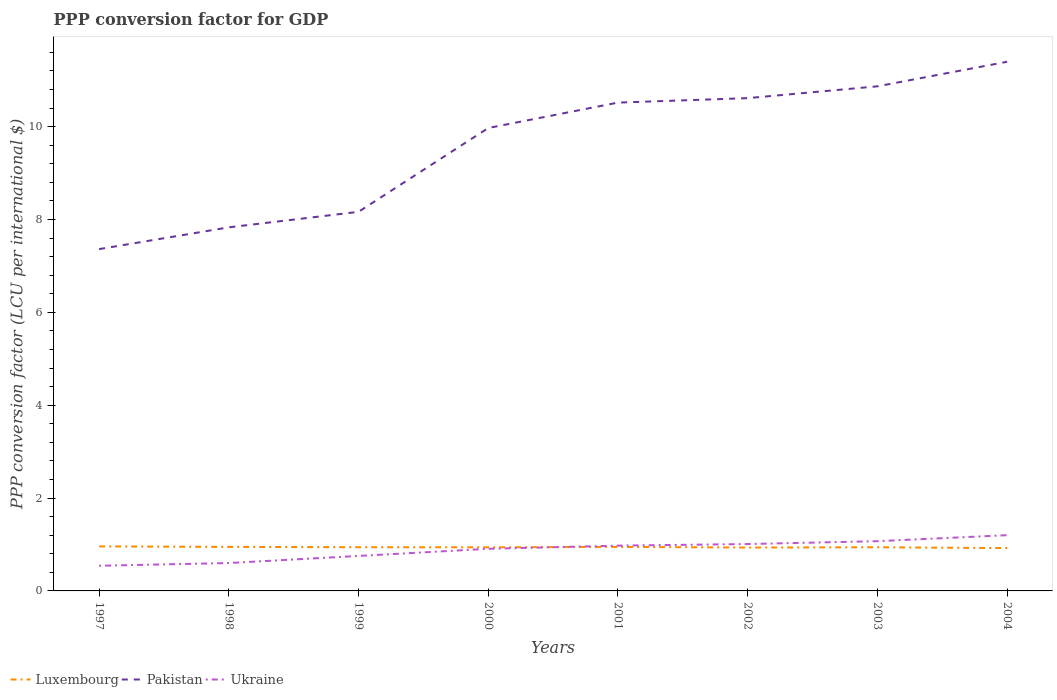How many different coloured lines are there?
Offer a very short reply. 3. Does the line corresponding to Luxembourg intersect with the line corresponding to Pakistan?
Provide a short and direct response. No. Across all years, what is the maximum PPP conversion factor for GDP in Luxembourg?
Offer a very short reply. 0.92. In which year was the PPP conversion factor for GDP in Pakistan maximum?
Your answer should be very brief. 1997. What is the total PPP conversion factor for GDP in Pakistan in the graph?
Make the answer very short. -0.8. What is the difference between the highest and the second highest PPP conversion factor for GDP in Ukraine?
Ensure brevity in your answer.  0.66. What is the difference between the highest and the lowest PPP conversion factor for GDP in Luxembourg?
Offer a terse response. 3. How many years are there in the graph?
Make the answer very short. 8. What is the difference between two consecutive major ticks on the Y-axis?
Your answer should be very brief. 2. Are the values on the major ticks of Y-axis written in scientific E-notation?
Keep it short and to the point. No. Does the graph contain any zero values?
Provide a short and direct response. No. Does the graph contain grids?
Provide a succinct answer. No. Where does the legend appear in the graph?
Your answer should be compact. Bottom left. How many legend labels are there?
Offer a very short reply. 3. What is the title of the graph?
Your answer should be compact. PPP conversion factor for GDP. What is the label or title of the X-axis?
Your answer should be very brief. Years. What is the label or title of the Y-axis?
Give a very brief answer. PPP conversion factor (LCU per international $). What is the PPP conversion factor (LCU per international $) of Luxembourg in 1997?
Offer a very short reply. 0.96. What is the PPP conversion factor (LCU per international $) of Pakistan in 1997?
Provide a short and direct response. 7.36. What is the PPP conversion factor (LCU per international $) in Ukraine in 1997?
Provide a succinct answer. 0.54. What is the PPP conversion factor (LCU per international $) in Luxembourg in 1998?
Your answer should be compact. 0.95. What is the PPP conversion factor (LCU per international $) in Pakistan in 1998?
Make the answer very short. 7.83. What is the PPP conversion factor (LCU per international $) in Ukraine in 1998?
Provide a short and direct response. 0.6. What is the PPP conversion factor (LCU per international $) in Luxembourg in 1999?
Offer a very short reply. 0.94. What is the PPP conversion factor (LCU per international $) in Pakistan in 1999?
Keep it short and to the point. 8.17. What is the PPP conversion factor (LCU per international $) of Ukraine in 1999?
Offer a terse response. 0.75. What is the PPP conversion factor (LCU per international $) of Luxembourg in 2000?
Your response must be concise. 0.94. What is the PPP conversion factor (LCU per international $) of Pakistan in 2000?
Keep it short and to the point. 9.97. What is the PPP conversion factor (LCU per international $) of Ukraine in 2000?
Your response must be concise. 0.91. What is the PPP conversion factor (LCU per international $) in Luxembourg in 2001?
Your response must be concise. 0.95. What is the PPP conversion factor (LCU per international $) in Pakistan in 2001?
Provide a succinct answer. 10.52. What is the PPP conversion factor (LCU per international $) in Ukraine in 2001?
Provide a short and direct response. 0.98. What is the PPP conversion factor (LCU per international $) of Luxembourg in 2002?
Ensure brevity in your answer.  0.93. What is the PPP conversion factor (LCU per international $) in Pakistan in 2002?
Keep it short and to the point. 10.61. What is the PPP conversion factor (LCU per international $) of Ukraine in 2002?
Make the answer very short. 1.01. What is the PPP conversion factor (LCU per international $) of Luxembourg in 2003?
Your answer should be very brief. 0.94. What is the PPP conversion factor (LCU per international $) of Pakistan in 2003?
Offer a very short reply. 10.87. What is the PPP conversion factor (LCU per international $) of Ukraine in 2003?
Your answer should be compact. 1.07. What is the PPP conversion factor (LCU per international $) of Luxembourg in 2004?
Give a very brief answer. 0.92. What is the PPP conversion factor (LCU per international $) of Pakistan in 2004?
Offer a terse response. 11.4. What is the PPP conversion factor (LCU per international $) in Ukraine in 2004?
Provide a succinct answer. 1.2. Across all years, what is the maximum PPP conversion factor (LCU per international $) of Luxembourg?
Your answer should be compact. 0.96. Across all years, what is the maximum PPP conversion factor (LCU per international $) of Pakistan?
Ensure brevity in your answer.  11.4. Across all years, what is the maximum PPP conversion factor (LCU per international $) in Ukraine?
Offer a very short reply. 1.2. Across all years, what is the minimum PPP conversion factor (LCU per international $) of Luxembourg?
Your answer should be very brief. 0.92. Across all years, what is the minimum PPP conversion factor (LCU per international $) of Pakistan?
Provide a short and direct response. 7.36. Across all years, what is the minimum PPP conversion factor (LCU per international $) of Ukraine?
Your answer should be compact. 0.54. What is the total PPP conversion factor (LCU per international $) of Luxembourg in the graph?
Provide a short and direct response. 7.53. What is the total PPP conversion factor (LCU per international $) of Pakistan in the graph?
Provide a succinct answer. 76.73. What is the total PPP conversion factor (LCU per international $) of Ukraine in the graph?
Provide a succinct answer. 7.06. What is the difference between the PPP conversion factor (LCU per international $) in Luxembourg in 1997 and that in 1998?
Your answer should be compact. 0.01. What is the difference between the PPP conversion factor (LCU per international $) in Pakistan in 1997 and that in 1998?
Your answer should be very brief. -0.47. What is the difference between the PPP conversion factor (LCU per international $) of Ukraine in 1997 and that in 1998?
Your answer should be very brief. -0.06. What is the difference between the PPP conversion factor (LCU per international $) in Luxembourg in 1997 and that in 1999?
Provide a short and direct response. 0.02. What is the difference between the PPP conversion factor (LCU per international $) in Pakistan in 1997 and that in 1999?
Keep it short and to the point. -0.8. What is the difference between the PPP conversion factor (LCU per international $) in Ukraine in 1997 and that in 1999?
Your response must be concise. -0.21. What is the difference between the PPP conversion factor (LCU per international $) in Luxembourg in 1997 and that in 2000?
Provide a succinct answer. 0.02. What is the difference between the PPP conversion factor (LCU per international $) of Pakistan in 1997 and that in 2000?
Your response must be concise. -2.61. What is the difference between the PPP conversion factor (LCU per international $) of Ukraine in 1997 and that in 2000?
Provide a short and direct response. -0.37. What is the difference between the PPP conversion factor (LCU per international $) in Luxembourg in 1997 and that in 2001?
Your answer should be compact. 0.01. What is the difference between the PPP conversion factor (LCU per international $) in Pakistan in 1997 and that in 2001?
Provide a short and direct response. -3.16. What is the difference between the PPP conversion factor (LCU per international $) of Ukraine in 1997 and that in 2001?
Make the answer very short. -0.43. What is the difference between the PPP conversion factor (LCU per international $) of Luxembourg in 1997 and that in 2002?
Your response must be concise. 0.02. What is the difference between the PPP conversion factor (LCU per international $) of Pakistan in 1997 and that in 2002?
Your answer should be compact. -3.25. What is the difference between the PPP conversion factor (LCU per international $) in Ukraine in 1997 and that in 2002?
Offer a very short reply. -0.47. What is the difference between the PPP conversion factor (LCU per international $) in Luxembourg in 1997 and that in 2003?
Your answer should be very brief. 0.02. What is the difference between the PPP conversion factor (LCU per international $) of Pakistan in 1997 and that in 2003?
Give a very brief answer. -3.51. What is the difference between the PPP conversion factor (LCU per international $) of Ukraine in 1997 and that in 2003?
Offer a terse response. -0.53. What is the difference between the PPP conversion factor (LCU per international $) in Luxembourg in 1997 and that in 2004?
Provide a succinct answer. 0.04. What is the difference between the PPP conversion factor (LCU per international $) of Pakistan in 1997 and that in 2004?
Your answer should be very brief. -4.04. What is the difference between the PPP conversion factor (LCU per international $) of Ukraine in 1997 and that in 2004?
Make the answer very short. -0.66. What is the difference between the PPP conversion factor (LCU per international $) of Luxembourg in 1998 and that in 1999?
Keep it short and to the point. 0.01. What is the difference between the PPP conversion factor (LCU per international $) of Pakistan in 1998 and that in 1999?
Your response must be concise. -0.33. What is the difference between the PPP conversion factor (LCU per international $) of Ukraine in 1998 and that in 1999?
Ensure brevity in your answer.  -0.15. What is the difference between the PPP conversion factor (LCU per international $) of Luxembourg in 1998 and that in 2000?
Keep it short and to the point. 0.01. What is the difference between the PPP conversion factor (LCU per international $) in Pakistan in 1998 and that in 2000?
Your answer should be very brief. -2.14. What is the difference between the PPP conversion factor (LCU per international $) of Ukraine in 1998 and that in 2000?
Your answer should be compact. -0.31. What is the difference between the PPP conversion factor (LCU per international $) of Luxembourg in 1998 and that in 2001?
Give a very brief answer. 0. What is the difference between the PPP conversion factor (LCU per international $) in Pakistan in 1998 and that in 2001?
Provide a short and direct response. -2.69. What is the difference between the PPP conversion factor (LCU per international $) of Ukraine in 1998 and that in 2001?
Your response must be concise. -0.37. What is the difference between the PPP conversion factor (LCU per international $) of Luxembourg in 1998 and that in 2002?
Make the answer very short. 0.01. What is the difference between the PPP conversion factor (LCU per international $) of Pakistan in 1998 and that in 2002?
Keep it short and to the point. -2.78. What is the difference between the PPP conversion factor (LCU per international $) in Ukraine in 1998 and that in 2002?
Give a very brief answer. -0.41. What is the difference between the PPP conversion factor (LCU per international $) in Luxembourg in 1998 and that in 2003?
Offer a terse response. 0.01. What is the difference between the PPP conversion factor (LCU per international $) in Pakistan in 1998 and that in 2003?
Make the answer very short. -3.04. What is the difference between the PPP conversion factor (LCU per international $) in Ukraine in 1998 and that in 2003?
Offer a terse response. -0.47. What is the difference between the PPP conversion factor (LCU per international $) of Luxembourg in 1998 and that in 2004?
Keep it short and to the point. 0.03. What is the difference between the PPP conversion factor (LCU per international $) in Pakistan in 1998 and that in 2004?
Keep it short and to the point. -3.57. What is the difference between the PPP conversion factor (LCU per international $) of Ukraine in 1998 and that in 2004?
Your response must be concise. -0.6. What is the difference between the PPP conversion factor (LCU per international $) of Luxembourg in 1999 and that in 2000?
Your response must be concise. 0. What is the difference between the PPP conversion factor (LCU per international $) of Pakistan in 1999 and that in 2000?
Give a very brief answer. -1.81. What is the difference between the PPP conversion factor (LCU per international $) in Ukraine in 1999 and that in 2000?
Your response must be concise. -0.15. What is the difference between the PPP conversion factor (LCU per international $) of Luxembourg in 1999 and that in 2001?
Ensure brevity in your answer.  -0.01. What is the difference between the PPP conversion factor (LCU per international $) of Pakistan in 1999 and that in 2001?
Provide a succinct answer. -2.35. What is the difference between the PPP conversion factor (LCU per international $) in Ukraine in 1999 and that in 2001?
Give a very brief answer. -0.22. What is the difference between the PPP conversion factor (LCU per international $) of Luxembourg in 1999 and that in 2002?
Your response must be concise. 0.01. What is the difference between the PPP conversion factor (LCU per international $) of Pakistan in 1999 and that in 2002?
Your response must be concise. -2.45. What is the difference between the PPP conversion factor (LCU per international $) of Ukraine in 1999 and that in 2002?
Your response must be concise. -0.26. What is the difference between the PPP conversion factor (LCU per international $) of Luxembourg in 1999 and that in 2003?
Your answer should be very brief. 0. What is the difference between the PPP conversion factor (LCU per international $) of Pakistan in 1999 and that in 2003?
Keep it short and to the point. -2.7. What is the difference between the PPP conversion factor (LCU per international $) in Ukraine in 1999 and that in 2003?
Your answer should be very brief. -0.32. What is the difference between the PPP conversion factor (LCU per international $) of Luxembourg in 1999 and that in 2004?
Your answer should be very brief. 0.02. What is the difference between the PPP conversion factor (LCU per international $) of Pakistan in 1999 and that in 2004?
Make the answer very short. -3.23. What is the difference between the PPP conversion factor (LCU per international $) of Ukraine in 1999 and that in 2004?
Keep it short and to the point. -0.45. What is the difference between the PPP conversion factor (LCU per international $) in Luxembourg in 2000 and that in 2001?
Provide a succinct answer. -0.01. What is the difference between the PPP conversion factor (LCU per international $) in Pakistan in 2000 and that in 2001?
Your answer should be very brief. -0.55. What is the difference between the PPP conversion factor (LCU per international $) in Ukraine in 2000 and that in 2001?
Ensure brevity in your answer.  -0.07. What is the difference between the PPP conversion factor (LCU per international $) of Luxembourg in 2000 and that in 2002?
Offer a terse response. 0.01. What is the difference between the PPP conversion factor (LCU per international $) in Pakistan in 2000 and that in 2002?
Offer a very short reply. -0.64. What is the difference between the PPP conversion factor (LCU per international $) in Ukraine in 2000 and that in 2002?
Your answer should be very brief. -0.1. What is the difference between the PPP conversion factor (LCU per international $) in Luxembourg in 2000 and that in 2003?
Make the answer very short. -0. What is the difference between the PPP conversion factor (LCU per international $) in Pakistan in 2000 and that in 2003?
Your answer should be compact. -0.9. What is the difference between the PPP conversion factor (LCU per international $) in Ukraine in 2000 and that in 2003?
Provide a short and direct response. -0.16. What is the difference between the PPP conversion factor (LCU per international $) in Luxembourg in 2000 and that in 2004?
Provide a succinct answer. 0.02. What is the difference between the PPP conversion factor (LCU per international $) in Pakistan in 2000 and that in 2004?
Ensure brevity in your answer.  -1.43. What is the difference between the PPP conversion factor (LCU per international $) of Ukraine in 2000 and that in 2004?
Your response must be concise. -0.29. What is the difference between the PPP conversion factor (LCU per international $) in Luxembourg in 2001 and that in 2002?
Your answer should be compact. 0.01. What is the difference between the PPP conversion factor (LCU per international $) of Pakistan in 2001 and that in 2002?
Offer a very short reply. -0.1. What is the difference between the PPP conversion factor (LCU per international $) in Ukraine in 2001 and that in 2002?
Provide a short and direct response. -0.03. What is the difference between the PPP conversion factor (LCU per international $) in Luxembourg in 2001 and that in 2003?
Make the answer very short. 0.01. What is the difference between the PPP conversion factor (LCU per international $) of Pakistan in 2001 and that in 2003?
Your answer should be compact. -0.35. What is the difference between the PPP conversion factor (LCU per international $) in Ukraine in 2001 and that in 2003?
Ensure brevity in your answer.  -0.1. What is the difference between the PPP conversion factor (LCU per international $) of Luxembourg in 2001 and that in 2004?
Offer a terse response. 0.03. What is the difference between the PPP conversion factor (LCU per international $) in Pakistan in 2001 and that in 2004?
Your answer should be compact. -0.88. What is the difference between the PPP conversion factor (LCU per international $) of Ukraine in 2001 and that in 2004?
Provide a succinct answer. -0.23. What is the difference between the PPP conversion factor (LCU per international $) in Luxembourg in 2002 and that in 2003?
Offer a very short reply. -0.01. What is the difference between the PPP conversion factor (LCU per international $) in Pakistan in 2002 and that in 2003?
Your response must be concise. -0.25. What is the difference between the PPP conversion factor (LCU per international $) in Ukraine in 2002 and that in 2003?
Give a very brief answer. -0.06. What is the difference between the PPP conversion factor (LCU per international $) of Luxembourg in 2002 and that in 2004?
Offer a terse response. 0.01. What is the difference between the PPP conversion factor (LCU per international $) in Pakistan in 2002 and that in 2004?
Offer a very short reply. -0.78. What is the difference between the PPP conversion factor (LCU per international $) in Ukraine in 2002 and that in 2004?
Make the answer very short. -0.19. What is the difference between the PPP conversion factor (LCU per international $) of Luxembourg in 2003 and that in 2004?
Offer a very short reply. 0.02. What is the difference between the PPP conversion factor (LCU per international $) in Pakistan in 2003 and that in 2004?
Provide a short and direct response. -0.53. What is the difference between the PPP conversion factor (LCU per international $) in Ukraine in 2003 and that in 2004?
Offer a terse response. -0.13. What is the difference between the PPP conversion factor (LCU per international $) in Luxembourg in 1997 and the PPP conversion factor (LCU per international $) in Pakistan in 1998?
Ensure brevity in your answer.  -6.87. What is the difference between the PPP conversion factor (LCU per international $) in Luxembourg in 1997 and the PPP conversion factor (LCU per international $) in Ukraine in 1998?
Offer a very short reply. 0.36. What is the difference between the PPP conversion factor (LCU per international $) of Pakistan in 1997 and the PPP conversion factor (LCU per international $) of Ukraine in 1998?
Your answer should be very brief. 6.76. What is the difference between the PPP conversion factor (LCU per international $) of Luxembourg in 1997 and the PPP conversion factor (LCU per international $) of Pakistan in 1999?
Offer a very short reply. -7.21. What is the difference between the PPP conversion factor (LCU per international $) in Luxembourg in 1997 and the PPP conversion factor (LCU per international $) in Ukraine in 1999?
Make the answer very short. 0.2. What is the difference between the PPP conversion factor (LCU per international $) in Pakistan in 1997 and the PPP conversion factor (LCU per international $) in Ukraine in 1999?
Your answer should be very brief. 6.61. What is the difference between the PPP conversion factor (LCU per international $) of Luxembourg in 1997 and the PPP conversion factor (LCU per international $) of Pakistan in 2000?
Offer a terse response. -9.01. What is the difference between the PPP conversion factor (LCU per international $) of Luxembourg in 1997 and the PPP conversion factor (LCU per international $) of Ukraine in 2000?
Keep it short and to the point. 0.05. What is the difference between the PPP conversion factor (LCU per international $) of Pakistan in 1997 and the PPP conversion factor (LCU per international $) of Ukraine in 2000?
Your answer should be compact. 6.45. What is the difference between the PPP conversion factor (LCU per international $) of Luxembourg in 1997 and the PPP conversion factor (LCU per international $) of Pakistan in 2001?
Offer a very short reply. -9.56. What is the difference between the PPP conversion factor (LCU per international $) in Luxembourg in 1997 and the PPP conversion factor (LCU per international $) in Ukraine in 2001?
Your answer should be very brief. -0.02. What is the difference between the PPP conversion factor (LCU per international $) of Pakistan in 1997 and the PPP conversion factor (LCU per international $) of Ukraine in 2001?
Give a very brief answer. 6.39. What is the difference between the PPP conversion factor (LCU per international $) of Luxembourg in 1997 and the PPP conversion factor (LCU per international $) of Pakistan in 2002?
Your answer should be very brief. -9.66. What is the difference between the PPP conversion factor (LCU per international $) in Luxembourg in 1997 and the PPP conversion factor (LCU per international $) in Ukraine in 2002?
Your answer should be very brief. -0.05. What is the difference between the PPP conversion factor (LCU per international $) in Pakistan in 1997 and the PPP conversion factor (LCU per international $) in Ukraine in 2002?
Make the answer very short. 6.35. What is the difference between the PPP conversion factor (LCU per international $) of Luxembourg in 1997 and the PPP conversion factor (LCU per international $) of Pakistan in 2003?
Offer a terse response. -9.91. What is the difference between the PPP conversion factor (LCU per international $) of Luxembourg in 1997 and the PPP conversion factor (LCU per international $) of Ukraine in 2003?
Provide a succinct answer. -0.11. What is the difference between the PPP conversion factor (LCU per international $) in Pakistan in 1997 and the PPP conversion factor (LCU per international $) in Ukraine in 2003?
Ensure brevity in your answer.  6.29. What is the difference between the PPP conversion factor (LCU per international $) in Luxembourg in 1997 and the PPP conversion factor (LCU per international $) in Pakistan in 2004?
Your answer should be very brief. -10.44. What is the difference between the PPP conversion factor (LCU per international $) of Luxembourg in 1997 and the PPP conversion factor (LCU per international $) of Ukraine in 2004?
Keep it short and to the point. -0.24. What is the difference between the PPP conversion factor (LCU per international $) in Pakistan in 1997 and the PPP conversion factor (LCU per international $) in Ukraine in 2004?
Provide a short and direct response. 6.16. What is the difference between the PPP conversion factor (LCU per international $) in Luxembourg in 1998 and the PPP conversion factor (LCU per international $) in Pakistan in 1999?
Your answer should be compact. -7.22. What is the difference between the PPP conversion factor (LCU per international $) of Luxembourg in 1998 and the PPP conversion factor (LCU per international $) of Ukraine in 1999?
Offer a very short reply. 0.19. What is the difference between the PPP conversion factor (LCU per international $) of Pakistan in 1998 and the PPP conversion factor (LCU per international $) of Ukraine in 1999?
Your answer should be very brief. 7.08. What is the difference between the PPP conversion factor (LCU per international $) in Luxembourg in 1998 and the PPP conversion factor (LCU per international $) in Pakistan in 2000?
Provide a short and direct response. -9.02. What is the difference between the PPP conversion factor (LCU per international $) in Luxembourg in 1998 and the PPP conversion factor (LCU per international $) in Ukraine in 2000?
Make the answer very short. 0.04. What is the difference between the PPP conversion factor (LCU per international $) of Pakistan in 1998 and the PPP conversion factor (LCU per international $) of Ukraine in 2000?
Ensure brevity in your answer.  6.92. What is the difference between the PPP conversion factor (LCU per international $) of Luxembourg in 1998 and the PPP conversion factor (LCU per international $) of Pakistan in 2001?
Make the answer very short. -9.57. What is the difference between the PPP conversion factor (LCU per international $) in Luxembourg in 1998 and the PPP conversion factor (LCU per international $) in Ukraine in 2001?
Keep it short and to the point. -0.03. What is the difference between the PPP conversion factor (LCU per international $) of Pakistan in 1998 and the PPP conversion factor (LCU per international $) of Ukraine in 2001?
Ensure brevity in your answer.  6.86. What is the difference between the PPP conversion factor (LCU per international $) of Luxembourg in 1998 and the PPP conversion factor (LCU per international $) of Pakistan in 2002?
Provide a short and direct response. -9.67. What is the difference between the PPP conversion factor (LCU per international $) in Luxembourg in 1998 and the PPP conversion factor (LCU per international $) in Ukraine in 2002?
Ensure brevity in your answer.  -0.06. What is the difference between the PPP conversion factor (LCU per international $) in Pakistan in 1998 and the PPP conversion factor (LCU per international $) in Ukraine in 2002?
Offer a very short reply. 6.82. What is the difference between the PPP conversion factor (LCU per international $) in Luxembourg in 1998 and the PPP conversion factor (LCU per international $) in Pakistan in 2003?
Your response must be concise. -9.92. What is the difference between the PPP conversion factor (LCU per international $) in Luxembourg in 1998 and the PPP conversion factor (LCU per international $) in Ukraine in 2003?
Offer a very short reply. -0.12. What is the difference between the PPP conversion factor (LCU per international $) in Pakistan in 1998 and the PPP conversion factor (LCU per international $) in Ukraine in 2003?
Provide a short and direct response. 6.76. What is the difference between the PPP conversion factor (LCU per international $) of Luxembourg in 1998 and the PPP conversion factor (LCU per international $) of Pakistan in 2004?
Ensure brevity in your answer.  -10.45. What is the difference between the PPP conversion factor (LCU per international $) of Luxembourg in 1998 and the PPP conversion factor (LCU per international $) of Ukraine in 2004?
Provide a succinct answer. -0.25. What is the difference between the PPP conversion factor (LCU per international $) of Pakistan in 1998 and the PPP conversion factor (LCU per international $) of Ukraine in 2004?
Offer a terse response. 6.63. What is the difference between the PPP conversion factor (LCU per international $) of Luxembourg in 1999 and the PPP conversion factor (LCU per international $) of Pakistan in 2000?
Ensure brevity in your answer.  -9.03. What is the difference between the PPP conversion factor (LCU per international $) of Luxembourg in 1999 and the PPP conversion factor (LCU per international $) of Ukraine in 2000?
Make the answer very short. 0.03. What is the difference between the PPP conversion factor (LCU per international $) in Pakistan in 1999 and the PPP conversion factor (LCU per international $) in Ukraine in 2000?
Keep it short and to the point. 7.26. What is the difference between the PPP conversion factor (LCU per international $) in Luxembourg in 1999 and the PPP conversion factor (LCU per international $) in Pakistan in 2001?
Make the answer very short. -9.58. What is the difference between the PPP conversion factor (LCU per international $) in Luxembourg in 1999 and the PPP conversion factor (LCU per international $) in Ukraine in 2001?
Provide a succinct answer. -0.03. What is the difference between the PPP conversion factor (LCU per international $) of Pakistan in 1999 and the PPP conversion factor (LCU per international $) of Ukraine in 2001?
Provide a short and direct response. 7.19. What is the difference between the PPP conversion factor (LCU per international $) in Luxembourg in 1999 and the PPP conversion factor (LCU per international $) in Pakistan in 2002?
Provide a short and direct response. -9.67. What is the difference between the PPP conversion factor (LCU per international $) in Luxembourg in 1999 and the PPP conversion factor (LCU per international $) in Ukraine in 2002?
Make the answer very short. -0.07. What is the difference between the PPP conversion factor (LCU per international $) in Pakistan in 1999 and the PPP conversion factor (LCU per international $) in Ukraine in 2002?
Your answer should be compact. 7.16. What is the difference between the PPP conversion factor (LCU per international $) of Luxembourg in 1999 and the PPP conversion factor (LCU per international $) of Pakistan in 2003?
Ensure brevity in your answer.  -9.93. What is the difference between the PPP conversion factor (LCU per international $) of Luxembourg in 1999 and the PPP conversion factor (LCU per international $) of Ukraine in 2003?
Offer a terse response. -0.13. What is the difference between the PPP conversion factor (LCU per international $) of Pakistan in 1999 and the PPP conversion factor (LCU per international $) of Ukraine in 2003?
Provide a succinct answer. 7.09. What is the difference between the PPP conversion factor (LCU per international $) of Luxembourg in 1999 and the PPP conversion factor (LCU per international $) of Pakistan in 2004?
Provide a succinct answer. -10.46. What is the difference between the PPP conversion factor (LCU per international $) of Luxembourg in 1999 and the PPP conversion factor (LCU per international $) of Ukraine in 2004?
Give a very brief answer. -0.26. What is the difference between the PPP conversion factor (LCU per international $) in Pakistan in 1999 and the PPP conversion factor (LCU per international $) in Ukraine in 2004?
Provide a succinct answer. 6.96. What is the difference between the PPP conversion factor (LCU per international $) of Luxembourg in 2000 and the PPP conversion factor (LCU per international $) of Pakistan in 2001?
Your response must be concise. -9.58. What is the difference between the PPP conversion factor (LCU per international $) in Luxembourg in 2000 and the PPP conversion factor (LCU per international $) in Ukraine in 2001?
Make the answer very short. -0.04. What is the difference between the PPP conversion factor (LCU per international $) of Pakistan in 2000 and the PPP conversion factor (LCU per international $) of Ukraine in 2001?
Your answer should be compact. 9. What is the difference between the PPP conversion factor (LCU per international $) in Luxembourg in 2000 and the PPP conversion factor (LCU per international $) in Pakistan in 2002?
Offer a very short reply. -9.67. What is the difference between the PPP conversion factor (LCU per international $) in Luxembourg in 2000 and the PPP conversion factor (LCU per international $) in Ukraine in 2002?
Offer a terse response. -0.07. What is the difference between the PPP conversion factor (LCU per international $) of Pakistan in 2000 and the PPP conversion factor (LCU per international $) of Ukraine in 2002?
Keep it short and to the point. 8.96. What is the difference between the PPP conversion factor (LCU per international $) in Luxembourg in 2000 and the PPP conversion factor (LCU per international $) in Pakistan in 2003?
Your answer should be compact. -9.93. What is the difference between the PPP conversion factor (LCU per international $) of Luxembourg in 2000 and the PPP conversion factor (LCU per international $) of Ukraine in 2003?
Ensure brevity in your answer.  -0.13. What is the difference between the PPP conversion factor (LCU per international $) in Pakistan in 2000 and the PPP conversion factor (LCU per international $) in Ukraine in 2003?
Provide a succinct answer. 8.9. What is the difference between the PPP conversion factor (LCU per international $) in Luxembourg in 2000 and the PPP conversion factor (LCU per international $) in Pakistan in 2004?
Make the answer very short. -10.46. What is the difference between the PPP conversion factor (LCU per international $) in Luxembourg in 2000 and the PPP conversion factor (LCU per international $) in Ukraine in 2004?
Your answer should be compact. -0.26. What is the difference between the PPP conversion factor (LCU per international $) in Pakistan in 2000 and the PPP conversion factor (LCU per international $) in Ukraine in 2004?
Provide a short and direct response. 8.77. What is the difference between the PPP conversion factor (LCU per international $) in Luxembourg in 2001 and the PPP conversion factor (LCU per international $) in Pakistan in 2002?
Your response must be concise. -9.67. What is the difference between the PPP conversion factor (LCU per international $) in Luxembourg in 2001 and the PPP conversion factor (LCU per international $) in Ukraine in 2002?
Provide a short and direct response. -0.06. What is the difference between the PPP conversion factor (LCU per international $) in Pakistan in 2001 and the PPP conversion factor (LCU per international $) in Ukraine in 2002?
Your answer should be very brief. 9.51. What is the difference between the PPP conversion factor (LCU per international $) of Luxembourg in 2001 and the PPP conversion factor (LCU per international $) of Pakistan in 2003?
Your answer should be compact. -9.92. What is the difference between the PPP conversion factor (LCU per international $) of Luxembourg in 2001 and the PPP conversion factor (LCU per international $) of Ukraine in 2003?
Offer a terse response. -0.12. What is the difference between the PPP conversion factor (LCU per international $) in Pakistan in 2001 and the PPP conversion factor (LCU per international $) in Ukraine in 2003?
Offer a terse response. 9.45. What is the difference between the PPP conversion factor (LCU per international $) of Luxembourg in 2001 and the PPP conversion factor (LCU per international $) of Pakistan in 2004?
Ensure brevity in your answer.  -10.45. What is the difference between the PPP conversion factor (LCU per international $) of Luxembourg in 2001 and the PPP conversion factor (LCU per international $) of Ukraine in 2004?
Your response must be concise. -0.25. What is the difference between the PPP conversion factor (LCU per international $) of Pakistan in 2001 and the PPP conversion factor (LCU per international $) of Ukraine in 2004?
Your answer should be very brief. 9.32. What is the difference between the PPP conversion factor (LCU per international $) in Luxembourg in 2002 and the PPP conversion factor (LCU per international $) in Pakistan in 2003?
Your answer should be compact. -9.93. What is the difference between the PPP conversion factor (LCU per international $) in Luxembourg in 2002 and the PPP conversion factor (LCU per international $) in Ukraine in 2003?
Make the answer very short. -0.14. What is the difference between the PPP conversion factor (LCU per international $) in Pakistan in 2002 and the PPP conversion factor (LCU per international $) in Ukraine in 2003?
Your response must be concise. 9.54. What is the difference between the PPP conversion factor (LCU per international $) of Luxembourg in 2002 and the PPP conversion factor (LCU per international $) of Pakistan in 2004?
Provide a succinct answer. -10.46. What is the difference between the PPP conversion factor (LCU per international $) in Luxembourg in 2002 and the PPP conversion factor (LCU per international $) in Ukraine in 2004?
Provide a short and direct response. -0.27. What is the difference between the PPP conversion factor (LCU per international $) of Pakistan in 2002 and the PPP conversion factor (LCU per international $) of Ukraine in 2004?
Your answer should be compact. 9.41. What is the difference between the PPP conversion factor (LCU per international $) in Luxembourg in 2003 and the PPP conversion factor (LCU per international $) in Pakistan in 2004?
Provide a succinct answer. -10.46. What is the difference between the PPP conversion factor (LCU per international $) of Luxembourg in 2003 and the PPP conversion factor (LCU per international $) of Ukraine in 2004?
Provide a short and direct response. -0.26. What is the difference between the PPP conversion factor (LCU per international $) of Pakistan in 2003 and the PPP conversion factor (LCU per international $) of Ukraine in 2004?
Make the answer very short. 9.67. What is the average PPP conversion factor (LCU per international $) of Luxembourg per year?
Give a very brief answer. 0.94. What is the average PPP conversion factor (LCU per international $) of Pakistan per year?
Your response must be concise. 9.59. What is the average PPP conversion factor (LCU per international $) of Ukraine per year?
Ensure brevity in your answer.  0.88. In the year 1997, what is the difference between the PPP conversion factor (LCU per international $) of Luxembourg and PPP conversion factor (LCU per international $) of Pakistan?
Offer a terse response. -6.4. In the year 1997, what is the difference between the PPP conversion factor (LCU per international $) in Luxembourg and PPP conversion factor (LCU per international $) in Ukraine?
Your answer should be very brief. 0.42. In the year 1997, what is the difference between the PPP conversion factor (LCU per international $) in Pakistan and PPP conversion factor (LCU per international $) in Ukraine?
Keep it short and to the point. 6.82. In the year 1998, what is the difference between the PPP conversion factor (LCU per international $) in Luxembourg and PPP conversion factor (LCU per international $) in Pakistan?
Your response must be concise. -6.88. In the year 1998, what is the difference between the PPP conversion factor (LCU per international $) in Luxembourg and PPP conversion factor (LCU per international $) in Ukraine?
Your answer should be compact. 0.35. In the year 1998, what is the difference between the PPP conversion factor (LCU per international $) of Pakistan and PPP conversion factor (LCU per international $) of Ukraine?
Your response must be concise. 7.23. In the year 1999, what is the difference between the PPP conversion factor (LCU per international $) of Luxembourg and PPP conversion factor (LCU per international $) of Pakistan?
Your answer should be very brief. -7.22. In the year 1999, what is the difference between the PPP conversion factor (LCU per international $) of Luxembourg and PPP conversion factor (LCU per international $) of Ukraine?
Your answer should be very brief. 0.19. In the year 1999, what is the difference between the PPP conversion factor (LCU per international $) of Pakistan and PPP conversion factor (LCU per international $) of Ukraine?
Make the answer very short. 7.41. In the year 2000, what is the difference between the PPP conversion factor (LCU per international $) in Luxembourg and PPP conversion factor (LCU per international $) in Pakistan?
Offer a terse response. -9.03. In the year 2000, what is the difference between the PPP conversion factor (LCU per international $) in Luxembourg and PPP conversion factor (LCU per international $) in Ukraine?
Your answer should be compact. 0.03. In the year 2000, what is the difference between the PPP conversion factor (LCU per international $) in Pakistan and PPP conversion factor (LCU per international $) in Ukraine?
Give a very brief answer. 9.06. In the year 2001, what is the difference between the PPP conversion factor (LCU per international $) in Luxembourg and PPP conversion factor (LCU per international $) in Pakistan?
Offer a very short reply. -9.57. In the year 2001, what is the difference between the PPP conversion factor (LCU per international $) of Luxembourg and PPP conversion factor (LCU per international $) of Ukraine?
Provide a short and direct response. -0.03. In the year 2001, what is the difference between the PPP conversion factor (LCU per international $) of Pakistan and PPP conversion factor (LCU per international $) of Ukraine?
Your response must be concise. 9.54. In the year 2002, what is the difference between the PPP conversion factor (LCU per international $) in Luxembourg and PPP conversion factor (LCU per international $) in Pakistan?
Your answer should be very brief. -9.68. In the year 2002, what is the difference between the PPP conversion factor (LCU per international $) in Luxembourg and PPP conversion factor (LCU per international $) in Ukraine?
Your answer should be very brief. -0.08. In the year 2002, what is the difference between the PPP conversion factor (LCU per international $) in Pakistan and PPP conversion factor (LCU per international $) in Ukraine?
Ensure brevity in your answer.  9.6. In the year 2003, what is the difference between the PPP conversion factor (LCU per international $) in Luxembourg and PPP conversion factor (LCU per international $) in Pakistan?
Make the answer very short. -9.93. In the year 2003, what is the difference between the PPP conversion factor (LCU per international $) in Luxembourg and PPP conversion factor (LCU per international $) in Ukraine?
Your response must be concise. -0.13. In the year 2003, what is the difference between the PPP conversion factor (LCU per international $) of Pakistan and PPP conversion factor (LCU per international $) of Ukraine?
Provide a short and direct response. 9.8. In the year 2004, what is the difference between the PPP conversion factor (LCU per international $) in Luxembourg and PPP conversion factor (LCU per international $) in Pakistan?
Give a very brief answer. -10.47. In the year 2004, what is the difference between the PPP conversion factor (LCU per international $) of Luxembourg and PPP conversion factor (LCU per international $) of Ukraine?
Your response must be concise. -0.28. In the year 2004, what is the difference between the PPP conversion factor (LCU per international $) in Pakistan and PPP conversion factor (LCU per international $) in Ukraine?
Ensure brevity in your answer.  10.2. What is the ratio of the PPP conversion factor (LCU per international $) of Luxembourg in 1997 to that in 1998?
Your answer should be compact. 1.01. What is the ratio of the PPP conversion factor (LCU per international $) of Pakistan in 1997 to that in 1998?
Keep it short and to the point. 0.94. What is the ratio of the PPP conversion factor (LCU per international $) of Ukraine in 1997 to that in 1998?
Provide a succinct answer. 0.9. What is the ratio of the PPP conversion factor (LCU per international $) of Luxembourg in 1997 to that in 1999?
Offer a very short reply. 1.02. What is the ratio of the PPP conversion factor (LCU per international $) of Pakistan in 1997 to that in 1999?
Keep it short and to the point. 0.9. What is the ratio of the PPP conversion factor (LCU per international $) in Ukraine in 1997 to that in 1999?
Make the answer very short. 0.72. What is the ratio of the PPP conversion factor (LCU per international $) of Luxembourg in 1997 to that in 2000?
Offer a very short reply. 1.02. What is the ratio of the PPP conversion factor (LCU per international $) in Pakistan in 1997 to that in 2000?
Make the answer very short. 0.74. What is the ratio of the PPP conversion factor (LCU per international $) of Ukraine in 1997 to that in 2000?
Make the answer very short. 0.6. What is the ratio of the PPP conversion factor (LCU per international $) in Luxembourg in 1997 to that in 2001?
Provide a short and direct response. 1.01. What is the ratio of the PPP conversion factor (LCU per international $) of Ukraine in 1997 to that in 2001?
Provide a succinct answer. 0.56. What is the ratio of the PPP conversion factor (LCU per international $) in Luxembourg in 1997 to that in 2002?
Offer a terse response. 1.03. What is the ratio of the PPP conversion factor (LCU per international $) of Pakistan in 1997 to that in 2002?
Keep it short and to the point. 0.69. What is the ratio of the PPP conversion factor (LCU per international $) of Ukraine in 1997 to that in 2002?
Make the answer very short. 0.54. What is the ratio of the PPP conversion factor (LCU per international $) of Luxembourg in 1997 to that in 2003?
Your answer should be very brief. 1.02. What is the ratio of the PPP conversion factor (LCU per international $) in Pakistan in 1997 to that in 2003?
Give a very brief answer. 0.68. What is the ratio of the PPP conversion factor (LCU per international $) of Ukraine in 1997 to that in 2003?
Keep it short and to the point. 0.51. What is the ratio of the PPP conversion factor (LCU per international $) of Luxembourg in 1997 to that in 2004?
Your answer should be compact. 1.04. What is the ratio of the PPP conversion factor (LCU per international $) in Pakistan in 1997 to that in 2004?
Your answer should be compact. 0.65. What is the ratio of the PPP conversion factor (LCU per international $) in Ukraine in 1997 to that in 2004?
Offer a very short reply. 0.45. What is the ratio of the PPP conversion factor (LCU per international $) in Luxembourg in 1998 to that in 1999?
Make the answer very short. 1.01. What is the ratio of the PPP conversion factor (LCU per international $) of Pakistan in 1998 to that in 1999?
Your response must be concise. 0.96. What is the ratio of the PPP conversion factor (LCU per international $) of Ukraine in 1998 to that in 1999?
Offer a terse response. 0.8. What is the ratio of the PPP conversion factor (LCU per international $) of Luxembourg in 1998 to that in 2000?
Provide a short and direct response. 1.01. What is the ratio of the PPP conversion factor (LCU per international $) of Pakistan in 1998 to that in 2000?
Offer a terse response. 0.79. What is the ratio of the PPP conversion factor (LCU per international $) of Ukraine in 1998 to that in 2000?
Offer a very short reply. 0.66. What is the ratio of the PPP conversion factor (LCU per international $) of Luxembourg in 1998 to that in 2001?
Your answer should be compact. 1. What is the ratio of the PPP conversion factor (LCU per international $) in Pakistan in 1998 to that in 2001?
Provide a short and direct response. 0.74. What is the ratio of the PPP conversion factor (LCU per international $) of Ukraine in 1998 to that in 2001?
Keep it short and to the point. 0.62. What is the ratio of the PPP conversion factor (LCU per international $) in Luxembourg in 1998 to that in 2002?
Keep it short and to the point. 1.02. What is the ratio of the PPP conversion factor (LCU per international $) in Pakistan in 1998 to that in 2002?
Your response must be concise. 0.74. What is the ratio of the PPP conversion factor (LCU per international $) of Ukraine in 1998 to that in 2002?
Your answer should be very brief. 0.59. What is the ratio of the PPP conversion factor (LCU per international $) in Luxembourg in 1998 to that in 2003?
Your response must be concise. 1.01. What is the ratio of the PPP conversion factor (LCU per international $) of Pakistan in 1998 to that in 2003?
Offer a terse response. 0.72. What is the ratio of the PPP conversion factor (LCU per international $) of Ukraine in 1998 to that in 2003?
Your answer should be very brief. 0.56. What is the ratio of the PPP conversion factor (LCU per international $) of Luxembourg in 1998 to that in 2004?
Your response must be concise. 1.03. What is the ratio of the PPP conversion factor (LCU per international $) in Pakistan in 1998 to that in 2004?
Keep it short and to the point. 0.69. What is the ratio of the PPP conversion factor (LCU per international $) of Ukraine in 1998 to that in 2004?
Provide a succinct answer. 0.5. What is the ratio of the PPP conversion factor (LCU per international $) of Pakistan in 1999 to that in 2000?
Your answer should be compact. 0.82. What is the ratio of the PPP conversion factor (LCU per international $) in Ukraine in 1999 to that in 2000?
Give a very brief answer. 0.83. What is the ratio of the PPP conversion factor (LCU per international $) in Luxembourg in 1999 to that in 2001?
Offer a very short reply. 0.99. What is the ratio of the PPP conversion factor (LCU per international $) of Pakistan in 1999 to that in 2001?
Offer a terse response. 0.78. What is the ratio of the PPP conversion factor (LCU per international $) in Ukraine in 1999 to that in 2001?
Your answer should be very brief. 0.77. What is the ratio of the PPP conversion factor (LCU per international $) in Luxembourg in 1999 to that in 2002?
Give a very brief answer. 1.01. What is the ratio of the PPP conversion factor (LCU per international $) in Pakistan in 1999 to that in 2002?
Provide a short and direct response. 0.77. What is the ratio of the PPP conversion factor (LCU per international $) of Ukraine in 1999 to that in 2002?
Ensure brevity in your answer.  0.75. What is the ratio of the PPP conversion factor (LCU per international $) of Luxembourg in 1999 to that in 2003?
Provide a short and direct response. 1. What is the ratio of the PPP conversion factor (LCU per international $) in Pakistan in 1999 to that in 2003?
Give a very brief answer. 0.75. What is the ratio of the PPP conversion factor (LCU per international $) in Ukraine in 1999 to that in 2003?
Offer a terse response. 0.7. What is the ratio of the PPP conversion factor (LCU per international $) in Luxembourg in 1999 to that in 2004?
Ensure brevity in your answer.  1.02. What is the ratio of the PPP conversion factor (LCU per international $) of Pakistan in 1999 to that in 2004?
Ensure brevity in your answer.  0.72. What is the ratio of the PPP conversion factor (LCU per international $) in Ukraine in 1999 to that in 2004?
Offer a terse response. 0.63. What is the ratio of the PPP conversion factor (LCU per international $) of Luxembourg in 2000 to that in 2001?
Offer a terse response. 0.99. What is the ratio of the PPP conversion factor (LCU per international $) in Pakistan in 2000 to that in 2001?
Give a very brief answer. 0.95. What is the ratio of the PPP conversion factor (LCU per international $) of Ukraine in 2000 to that in 2001?
Provide a succinct answer. 0.93. What is the ratio of the PPP conversion factor (LCU per international $) in Pakistan in 2000 to that in 2002?
Make the answer very short. 0.94. What is the ratio of the PPP conversion factor (LCU per international $) in Ukraine in 2000 to that in 2002?
Offer a terse response. 0.9. What is the ratio of the PPP conversion factor (LCU per international $) in Luxembourg in 2000 to that in 2003?
Your answer should be compact. 1. What is the ratio of the PPP conversion factor (LCU per international $) of Pakistan in 2000 to that in 2003?
Provide a succinct answer. 0.92. What is the ratio of the PPP conversion factor (LCU per international $) of Ukraine in 2000 to that in 2003?
Your answer should be compact. 0.85. What is the ratio of the PPP conversion factor (LCU per international $) in Luxembourg in 2000 to that in 2004?
Offer a terse response. 1.02. What is the ratio of the PPP conversion factor (LCU per international $) of Pakistan in 2000 to that in 2004?
Provide a short and direct response. 0.87. What is the ratio of the PPP conversion factor (LCU per international $) in Ukraine in 2000 to that in 2004?
Keep it short and to the point. 0.76. What is the ratio of the PPP conversion factor (LCU per international $) of Luxembourg in 2001 to that in 2002?
Offer a very short reply. 1.01. What is the ratio of the PPP conversion factor (LCU per international $) in Pakistan in 2001 to that in 2002?
Your response must be concise. 0.99. What is the ratio of the PPP conversion factor (LCU per international $) of Ukraine in 2001 to that in 2002?
Your response must be concise. 0.97. What is the ratio of the PPP conversion factor (LCU per international $) of Luxembourg in 2001 to that in 2003?
Provide a short and direct response. 1.01. What is the ratio of the PPP conversion factor (LCU per international $) in Pakistan in 2001 to that in 2003?
Your answer should be compact. 0.97. What is the ratio of the PPP conversion factor (LCU per international $) of Ukraine in 2001 to that in 2003?
Your response must be concise. 0.91. What is the ratio of the PPP conversion factor (LCU per international $) in Luxembourg in 2001 to that in 2004?
Keep it short and to the point. 1.03. What is the ratio of the PPP conversion factor (LCU per international $) of Pakistan in 2001 to that in 2004?
Offer a very short reply. 0.92. What is the ratio of the PPP conversion factor (LCU per international $) in Ukraine in 2001 to that in 2004?
Give a very brief answer. 0.81. What is the ratio of the PPP conversion factor (LCU per international $) of Pakistan in 2002 to that in 2003?
Offer a very short reply. 0.98. What is the ratio of the PPP conversion factor (LCU per international $) of Ukraine in 2002 to that in 2003?
Give a very brief answer. 0.94. What is the ratio of the PPP conversion factor (LCU per international $) of Luxembourg in 2002 to that in 2004?
Offer a very short reply. 1.01. What is the ratio of the PPP conversion factor (LCU per international $) of Pakistan in 2002 to that in 2004?
Make the answer very short. 0.93. What is the ratio of the PPP conversion factor (LCU per international $) in Ukraine in 2002 to that in 2004?
Keep it short and to the point. 0.84. What is the ratio of the PPP conversion factor (LCU per international $) of Luxembourg in 2003 to that in 2004?
Your answer should be compact. 1.02. What is the ratio of the PPP conversion factor (LCU per international $) of Pakistan in 2003 to that in 2004?
Provide a short and direct response. 0.95. What is the ratio of the PPP conversion factor (LCU per international $) of Ukraine in 2003 to that in 2004?
Keep it short and to the point. 0.89. What is the difference between the highest and the second highest PPP conversion factor (LCU per international $) of Luxembourg?
Your answer should be very brief. 0.01. What is the difference between the highest and the second highest PPP conversion factor (LCU per international $) of Pakistan?
Your answer should be compact. 0.53. What is the difference between the highest and the second highest PPP conversion factor (LCU per international $) in Ukraine?
Ensure brevity in your answer.  0.13. What is the difference between the highest and the lowest PPP conversion factor (LCU per international $) of Luxembourg?
Make the answer very short. 0.04. What is the difference between the highest and the lowest PPP conversion factor (LCU per international $) of Pakistan?
Your answer should be compact. 4.04. What is the difference between the highest and the lowest PPP conversion factor (LCU per international $) of Ukraine?
Your response must be concise. 0.66. 